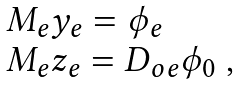<formula> <loc_0><loc_0><loc_500><loc_500>\begin{array} { l } M _ { e } y _ { e } = \phi _ { e } \\ M _ { e } z _ { e } = D _ { o e } \phi _ { 0 } \ , \end{array}</formula> 